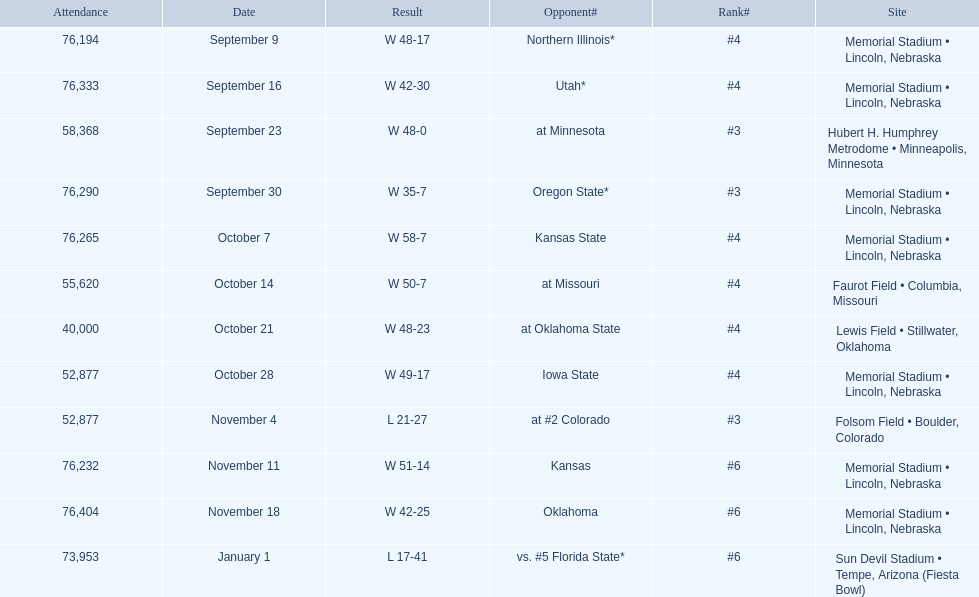How many games did they win by more than 7? 10. 